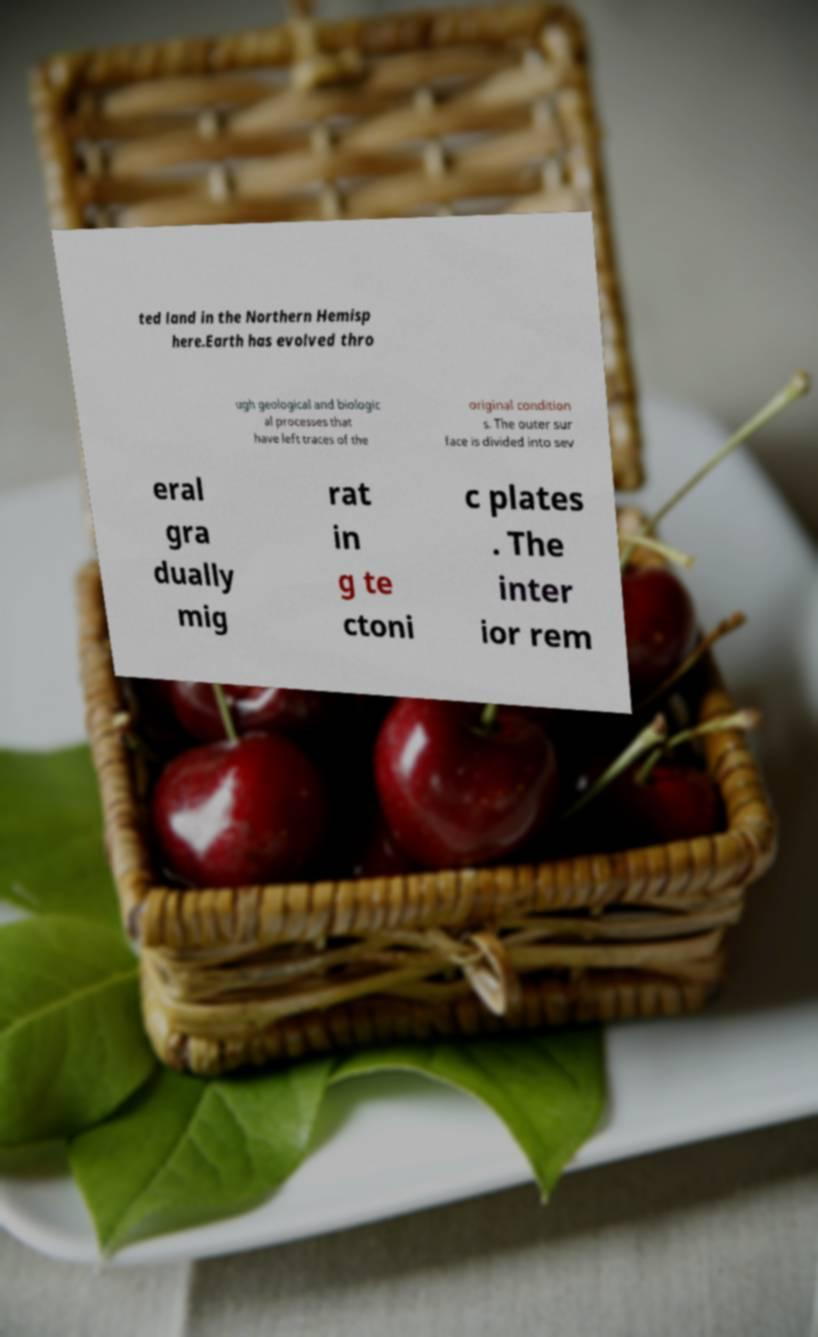Can you read and provide the text displayed in the image?This photo seems to have some interesting text. Can you extract and type it out for me? ted land in the Northern Hemisp here.Earth has evolved thro ugh geological and biologic al processes that have left traces of the original condition s. The outer sur face is divided into sev eral gra dually mig rat in g te ctoni c plates . The inter ior rem 